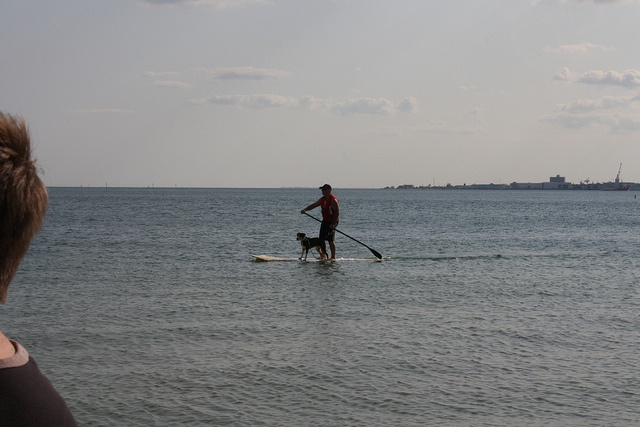Describe the objects in this image and their specific colors. I can see people in darkgray, black, maroon, and gray tones, people in darkgray, black, gray, and maroon tones, boat in darkgray, gray, and black tones, dog in darkgray, black, and gray tones, and surfboard in darkgray, gray, black, and tan tones in this image. 